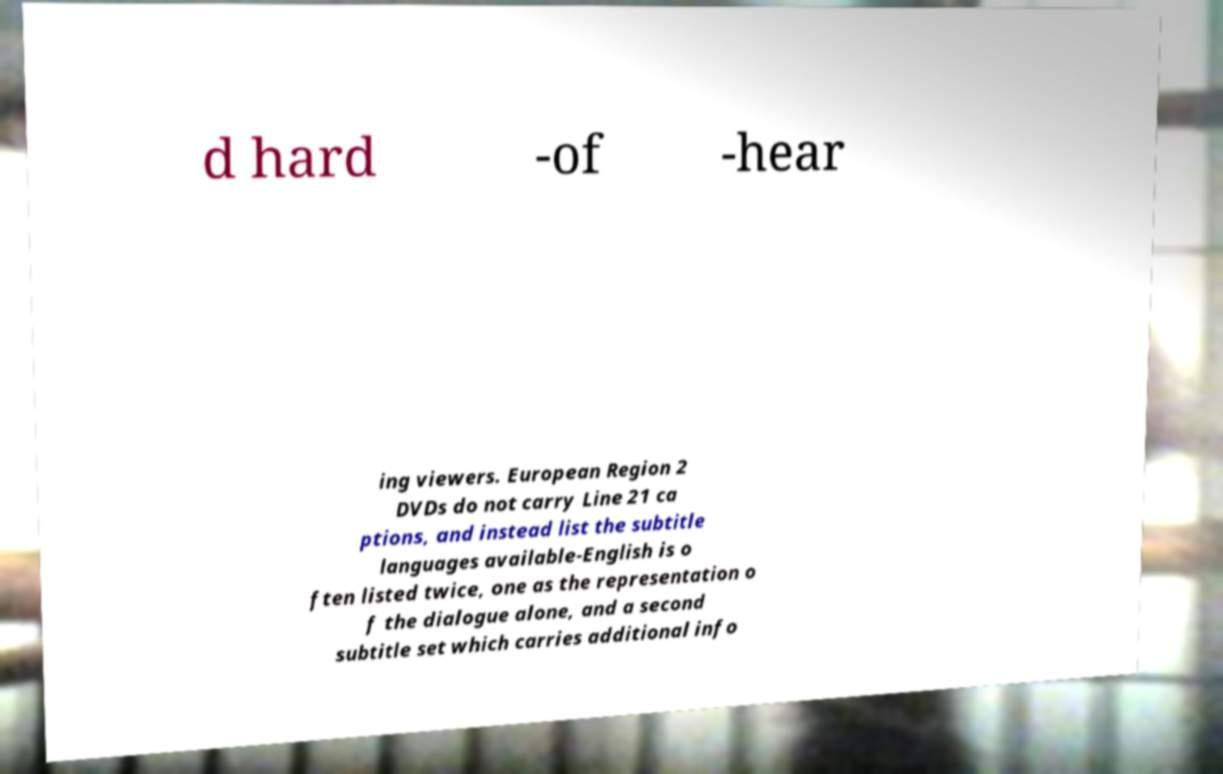I need the written content from this picture converted into text. Can you do that? d hard -of -hear ing viewers. European Region 2 DVDs do not carry Line 21 ca ptions, and instead list the subtitle languages available-English is o ften listed twice, one as the representation o f the dialogue alone, and a second subtitle set which carries additional info 